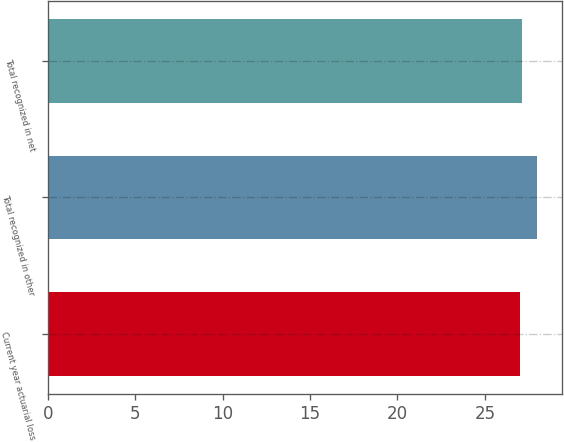Convert chart to OTSL. <chart><loc_0><loc_0><loc_500><loc_500><bar_chart><fcel>Current year actuarial loss<fcel>Total recognized in other<fcel>Total recognized in net<nl><fcel>27<fcel>28<fcel>27.1<nl></chart> 